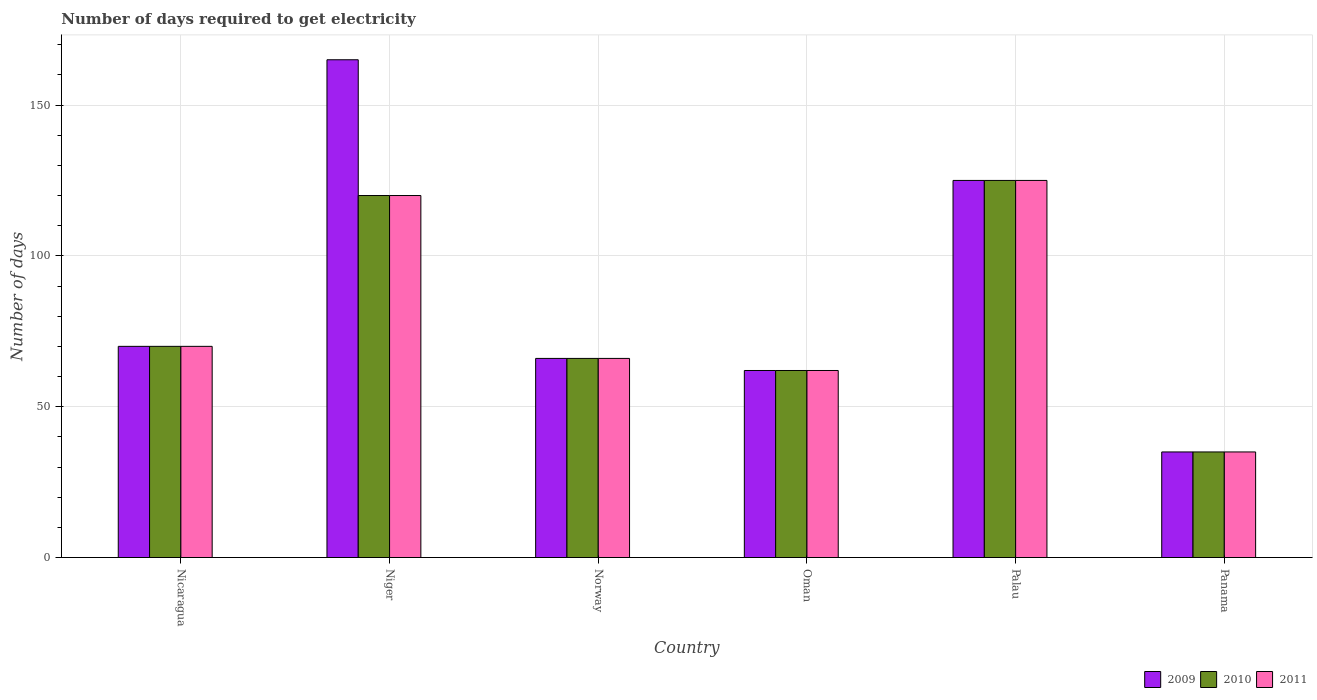Are the number of bars per tick equal to the number of legend labels?
Make the answer very short. Yes. How many bars are there on the 5th tick from the right?
Keep it short and to the point. 3. What is the label of the 4th group of bars from the left?
Offer a terse response. Oman. In how many cases, is the number of bars for a given country not equal to the number of legend labels?
Offer a terse response. 0. Across all countries, what is the maximum number of days required to get electricity in in 2011?
Your response must be concise. 125. Across all countries, what is the minimum number of days required to get electricity in in 2009?
Provide a succinct answer. 35. In which country was the number of days required to get electricity in in 2011 maximum?
Make the answer very short. Palau. In which country was the number of days required to get electricity in in 2009 minimum?
Offer a terse response. Panama. What is the total number of days required to get electricity in in 2009 in the graph?
Your answer should be compact. 523. What is the difference between the number of days required to get electricity in in 2010 in Nicaragua and that in Panama?
Your answer should be compact. 35. What is the average number of days required to get electricity in in 2009 per country?
Offer a very short reply. 87.17. What is the ratio of the number of days required to get electricity in in 2009 in Norway to that in Oman?
Offer a terse response. 1.06. Is the difference between the number of days required to get electricity in in 2010 in Palau and Panama greater than the difference between the number of days required to get electricity in in 2009 in Palau and Panama?
Give a very brief answer. No. What is the difference between the highest and the second highest number of days required to get electricity in in 2009?
Your answer should be compact. -40. In how many countries, is the number of days required to get electricity in in 2010 greater than the average number of days required to get electricity in in 2010 taken over all countries?
Ensure brevity in your answer.  2. Is the sum of the number of days required to get electricity in in 2011 in Nicaragua and Panama greater than the maximum number of days required to get electricity in in 2009 across all countries?
Give a very brief answer. No. What does the 1st bar from the right in Norway represents?
Provide a succinct answer. 2011. How many bars are there?
Your response must be concise. 18. Are all the bars in the graph horizontal?
Offer a very short reply. No. Are the values on the major ticks of Y-axis written in scientific E-notation?
Offer a very short reply. No. Does the graph contain grids?
Offer a very short reply. Yes. How are the legend labels stacked?
Offer a very short reply. Horizontal. What is the title of the graph?
Your answer should be very brief. Number of days required to get electricity. What is the label or title of the X-axis?
Provide a succinct answer. Country. What is the label or title of the Y-axis?
Keep it short and to the point. Number of days. What is the Number of days in 2009 in Nicaragua?
Offer a very short reply. 70. What is the Number of days of 2010 in Nicaragua?
Provide a succinct answer. 70. What is the Number of days of 2011 in Nicaragua?
Make the answer very short. 70. What is the Number of days in 2009 in Niger?
Make the answer very short. 165. What is the Number of days in 2010 in Niger?
Ensure brevity in your answer.  120. What is the Number of days in 2011 in Niger?
Provide a short and direct response. 120. What is the Number of days of 2009 in Norway?
Your answer should be very brief. 66. What is the Number of days in 2010 in Oman?
Your answer should be very brief. 62. What is the Number of days in 2011 in Oman?
Provide a succinct answer. 62. What is the Number of days of 2009 in Palau?
Make the answer very short. 125. What is the Number of days of 2010 in Palau?
Your answer should be compact. 125. What is the Number of days in 2011 in Palau?
Offer a terse response. 125. What is the Number of days in 2010 in Panama?
Your answer should be compact. 35. What is the Number of days in 2011 in Panama?
Keep it short and to the point. 35. Across all countries, what is the maximum Number of days of 2009?
Provide a short and direct response. 165. Across all countries, what is the maximum Number of days in 2010?
Your answer should be very brief. 125. Across all countries, what is the maximum Number of days in 2011?
Offer a very short reply. 125. Across all countries, what is the minimum Number of days in 2009?
Your answer should be very brief. 35. Across all countries, what is the minimum Number of days in 2010?
Your answer should be compact. 35. What is the total Number of days of 2009 in the graph?
Keep it short and to the point. 523. What is the total Number of days in 2010 in the graph?
Offer a very short reply. 478. What is the total Number of days of 2011 in the graph?
Your answer should be very brief. 478. What is the difference between the Number of days of 2009 in Nicaragua and that in Niger?
Your response must be concise. -95. What is the difference between the Number of days in 2010 in Nicaragua and that in Niger?
Your answer should be very brief. -50. What is the difference between the Number of days of 2009 in Nicaragua and that in Norway?
Provide a short and direct response. 4. What is the difference between the Number of days of 2011 in Nicaragua and that in Norway?
Provide a succinct answer. 4. What is the difference between the Number of days in 2009 in Nicaragua and that in Palau?
Provide a succinct answer. -55. What is the difference between the Number of days of 2010 in Nicaragua and that in Palau?
Your response must be concise. -55. What is the difference between the Number of days in 2011 in Nicaragua and that in Palau?
Your answer should be compact. -55. What is the difference between the Number of days in 2010 in Niger and that in Norway?
Offer a terse response. 54. What is the difference between the Number of days in 2011 in Niger and that in Norway?
Offer a very short reply. 54. What is the difference between the Number of days in 2009 in Niger and that in Oman?
Provide a succinct answer. 103. What is the difference between the Number of days of 2010 in Niger and that in Oman?
Your answer should be compact. 58. What is the difference between the Number of days in 2009 in Niger and that in Palau?
Provide a succinct answer. 40. What is the difference between the Number of days in 2009 in Niger and that in Panama?
Your response must be concise. 130. What is the difference between the Number of days in 2010 in Niger and that in Panama?
Offer a very short reply. 85. What is the difference between the Number of days in 2009 in Norway and that in Oman?
Provide a short and direct response. 4. What is the difference between the Number of days of 2010 in Norway and that in Oman?
Your response must be concise. 4. What is the difference between the Number of days of 2009 in Norway and that in Palau?
Give a very brief answer. -59. What is the difference between the Number of days in 2010 in Norway and that in Palau?
Offer a terse response. -59. What is the difference between the Number of days in 2011 in Norway and that in Palau?
Offer a terse response. -59. What is the difference between the Number of days in 2010 in Norway and that in Panama?
Provide a short and direct response. 31. What is the difference between the Number of days of 2009 in Oman and that in Palau?
Provide a succinct answer. -63. What is the difference between the Number of days in 2010 in Oman and that in Palau?
Ensure brevity in your answer.  -63. What is the difference between the Number of days of 2011 in Oman and that in Palau?
Offer a very short reply. -63. What is the difference between the Number of days in 2010 in Oman and that in Panama?
Your answer should be compact. 27. What is the difference between the Number of days of 2009 in Palau and that in Panama?
Make the answer very short. 90. What is the difference between the Number of days of 2011 in Palau and that in Panama?
Give a very brief answer. 90. What is the difference between the Number of days in 2009 in Nicaragua and the Number of days in 2011 in Niger?
Provide a succinct answer. -50. What is the difference between the Number of days of 2010 in Nicaragua and the Number of days of 2011 in Niger?
Ensure brevity in your answer.  -50. What is the difference between the Number of days of 2010 in Nicaragua and the Number of days of 2011 in Oman?
Provide a short and direct response. 8. What is the difference between the Number of days of 2009 in Nicaragua and the Number of days of 2010 in Palau?
Your response must be concise. -55. What is the difference between the Number of days of 2009 in Nicaragua and the Number of days of 2011 in Palau?
Your answer should be compact. -55. What is the difference between the Number of days of 2010 in Nicaragua and the Number of days of 2011 in Palau?
Your answer should be compact. -55. What is the difference between the Number of days in 2010 in Nicaragua and the Number of days in 2011 in Panama?
Provide a succinct answer. 35. What is the difference between the Number of days in 2009 in Niger and the Number of days in 2011 in Norway?
Offer a very short reply. 99. What is the difference between the Number of days in 2010 in Niger and the Number of days in 2011 in Norway?
Your answer should be very brief. 54. What is the difference between the Number of days in 2009 in Niger and the Number of days in 2010 in Oman?
Offer a terse response. 103. What is the difference between the Number of days in 2009 in Niger and the Number of days in 2011 in Oman?
Your answer should be compact. 103. What is the difference between the Number of days of 2009 in Niger and the Number of days of 2011 in Palau?
Your answer should be compact. 40. What is the difference between the Number of days in 2009 in Niger and the Number of days in 2010 in Panama?
Ensure brevity in your answer.  130. What is the difference between the Number of days of 2009 in Niger and the Number of days of 2011 in Panama?
Your response must be concise. 130. What is the difference between the Number of days of 2009 in Norway and the Number of days of 2010 in Oman?
Your answer should be compact. 4. What is the difference between the Number of days of 2009 in Norway and the Number of days of 2010 in Palau?
Keep it short and to the point. -59. What is the difference between the Number of days in 2009 in Norway and the Number of days in 2011 in Palau?
Your response must be concise. -59. What is the difference between the Number of days of 2010 in Norway and the Number of days of 2011 in Palau?
Offer a very short reply. -59. What is the difference between the Number of days in 2009 in Norway and the Number of days in 2010 in Panama?
Give a very brief answer. 31. What is the difference between the Number of days in 2009 in Oman and the Number of days in 2010 in Palau?
Provide a succinct answer. -63. What is the difference between the Number of days in 2009 in Oman and the Number of days in 2011 in Palau?
Your answer should be very brief. -63. What is the difference between the Number of days in 2010 in Oman and the Number of days in 2011 in Palau?
Provide a short and direct response. -63. What is the difference between the Number of days of 2009 in Oman and the Number of days of 2011 in Panama?
Your response must be concise. 27. What is the difference between the Number of days in 2010 in Oman and the Number of days in 2011 in Panama?
Provide a succinct answer. 27. What is the difference between the Number of days in 2010 in Palau and the Number of days in 2011 in Panama?
Offer a terse response. 90. What is the average Number of days in 2009 per country?
Make the answer very short. 87.17. What is the average Number of days in 2010 per country?
Offer a terse response. 79.67. What is the average Number of days of 2011 per country?
Your answer should be compact. 79.67. What is the difference between the Number of days in 2009 and Number of days in 2011 in Niger?
Offer a terse response. 45. What is the difference between the Number of days in 2010 and Number of days in 2011 in Niger?
Provide a succinct answer. 0. What is the difference between the Number of days of 2009 and Number of days of 2010 in Oman?
Keep it short and to the point. 0. What is the difference between the Number of days of 2009 and Number of days of 2011 in Oman?
Offer a very short reply. 0. What is the difference between the Number of days of 2010 and Number of days of 2011 in Oman?
Provide a succinct answer. 0. What is the ratio of the Number of days of 2009 in Nicaragua to that in Niger?
Provide a succinct answer. 0.42. What is the ratio of the Number of days of 2010 in Nicaragua to that in Niger?
Keep it short and to the point. 0.58. What is the ratio of the Number of days in 2011 in Nicaragua to that in Niger?
Your answer should be compact. 0.58. What is the ratio of the Number of days in 2009 in Nicaragua to that in Norway?
Ensure brevity in your answer.  1.06. What is the ratio of the Number of days in 2010 in Nicaragua to that in Norway?
Your response must be concise. 1.06. What is the ratio of the Number of days of 2011 in Nicaragua to that in Norway?
Offer a very short reply. 1.06. What is the ratio of the Number of days in 2009 in Nicaragua to that in Oman?
Provide a short and direct response. 1.13. What is the ratio of the Number of days in 2010 in Nicaragua to that in Oman?
Keep it short and to the point. 1.13. What is the ratio of the Number of days in 2011 in Nicaragua to that in Oman?
Provide a succinct answer. 1.13. What is the ratio of the Number of days of 2009 in Nicaragua to that in Palau?
Offer a very short reply. 0.56. What is the ratio of the Number of days of 2010 in Nicaragua to that in Palau?
Your answer should be very brief. 0.56. What is the ratio of the Number of days in 2011 in Nicaragua to that in Palau?
Your answer should be very brief. 0.56. What is the ratio of the Number of days of 2009 in Nicaragua to that in Panama?
Offer a very short reply. 2. What is the ratio of the Number of days of 2010 in Nicaragua to that in Panama?
Offer a very short reply. 2. What is the ratio of the Number of days of 2009 in Niger to that in Norway?
Your response must be concise. 2.5. What is the ratio of the Number of days in 2010 in Niger to that in Norway?
Offer a very short reply. 1.82. What is the ratio of the Number of days of 2011 in Niger to that in Norway?
Give a very brief answer. 1.82. What is the ratio of the Number of days in 2009 in Niger to that in Oman?
Offer a very short reply. 2.66. What is the ratio of the Number of days of 2010 in Niger to that in Oman?
Make the answer very short. 1.94. What is the ratio of the Number of days of 2011 in Niger to that in Oman?
Your answer should be very brief. 1.94. What is the ratio of the Number of days in 2009 in Niger to that in Palau?
Provide a short and direct response. 1.32. What is the ratio of the Number of days in 2010 in Niger to that in Palau?
Your answer should be very brief. 0.96. What is the ratio of the Number of days in 2011 in Niger to that in Palau?
Provide a short and direct response. 0.96. What is the ratio of the Number of days in 2009 in Niger to that in Panama?
Provide a succinct answer. 4.71. What is the ratio of the Number of days in 2010 in Niger to that in Panama?
Your answer should be very brief. 3.43. What is the ratio of the Number of days of 2011 in Niger to that in Panama?
Your answer should be compact. 3.43. What is the ratio of the Number of days of 2009 in Norway to that in Oman?
Your response must be concise. 1.06. What is the ratio of the Number of days in 2010 in Norway to that in Oman?
Offer a terse response. 1.06. What is the ratio of the Number of days of 2011 in Norway to that in Oman?
Provide a short and direct response. 1.06. What is the ratio of the Number of days of 2009 in Norway to that in Palau?
Give a very brief answer. 0.53. What is the ratio of the Number of days in 2010 in Norway to that in Palau?
Provide a short and direct response. 0.53. What is the ratio of the Number of days in 2011 in Norway to that in Palau?
Give a very brief answer. 0.53. What is the ratio of the Number of days in 2009 in Norway to that in Panama?
Provide a short and direct response. 1.89. What is the ratio of the Number of days of 2010 in Norway to that in Panama?
Provide a short and direct response. 1.89. What is the ratio of the Number of days of 2011 in Norway to that in Panama?
Offer a terse response. 1.89. What is the ratio of the Number of days of 2009 in Oman to that in Palau?
Make the answer very short. 0.5. What is the ratio of the Number of days in 2010 in Oman to that in Palau?
Make the answer very short. 0.5. What is the ratio of the Number of days of 2011 in Oman to that in Palau?
Offer a terse response. 0.5. What is the ratio of the Number of days of 2009 in Oman to that in Panama?
Offer a very short reply. 1.77. What is the ratio of the Number of days of 2010 in Oman to that in Panama?
Keep it short and to the point. 1.77. What is the ratio of the Number of days of 2011 in Oman to that in Panama?
Your response must be concise. 1.77. What is the ratio of the Number of days of 2009 in Palau to that in Panama?
Give a very brief answer. 3.57. What is the ratio of the Number of days of 2010 in Palau to that in Panama?
Provide a short and direct response. 3.57. What is the ratio of the Number of days in 2011 in Palau to that in Panama?
Provide a succinct answer. 3.57. What is the difference between the highest and the second highest Number of days in 2009?
Ensure brevity in your answer.  40. What is the difference between the highest and the second highest Number of days in 2010?
Offer a very short reply. 5. What is the difference between the highest and the lowest Number of days of 2009?
Ensure brevity in your answer.  130. What is the difference between the highest and the lowest Number of days of 2011?
Give a very brief answer. 90. 